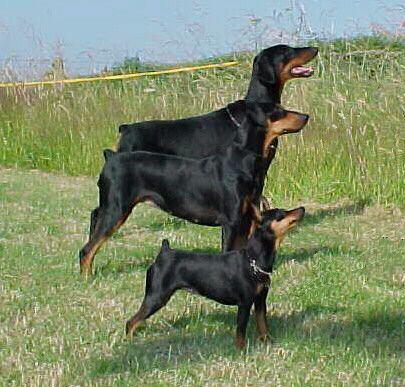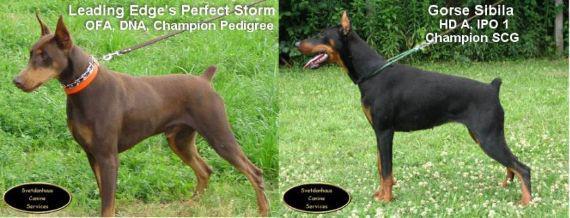The first image is the image on the left, the second image is the image on the right. Assess this claim about the two images: "There are only two dogs.". Correct or not? Answer yes or no. No. The first image is the image on the left, the second image is the image on the right. Examine the images to the left and right. Is the description "There are exactly two dogs." accurate? Answer yes or no. No. 